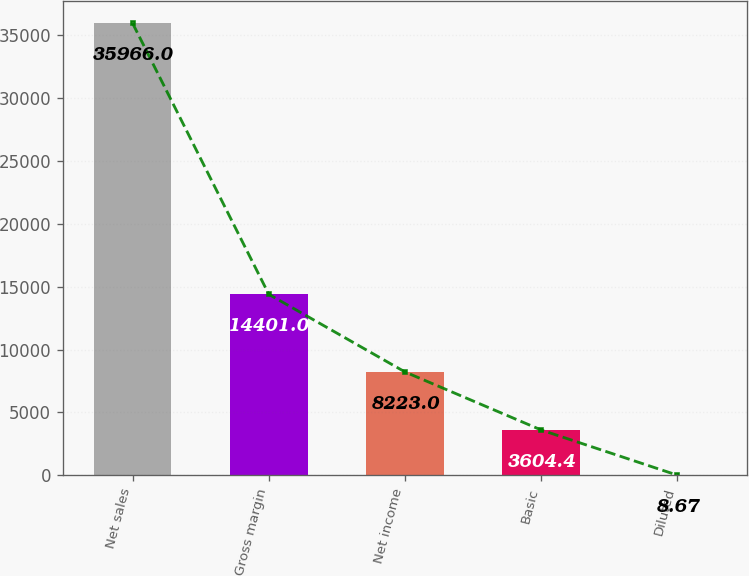Convert chart. <chart><loc_0><loc_0><loc_500><loc_500><bar_chart><fcel>Net sales<fcel>Gross margin<fcel>Net income<fcel>Basic<fcel>Diluted<nl><fcel>35966<fcel>14401<fcel>8223<fcel>3604.4<fcel>8.67<nl></chart> 